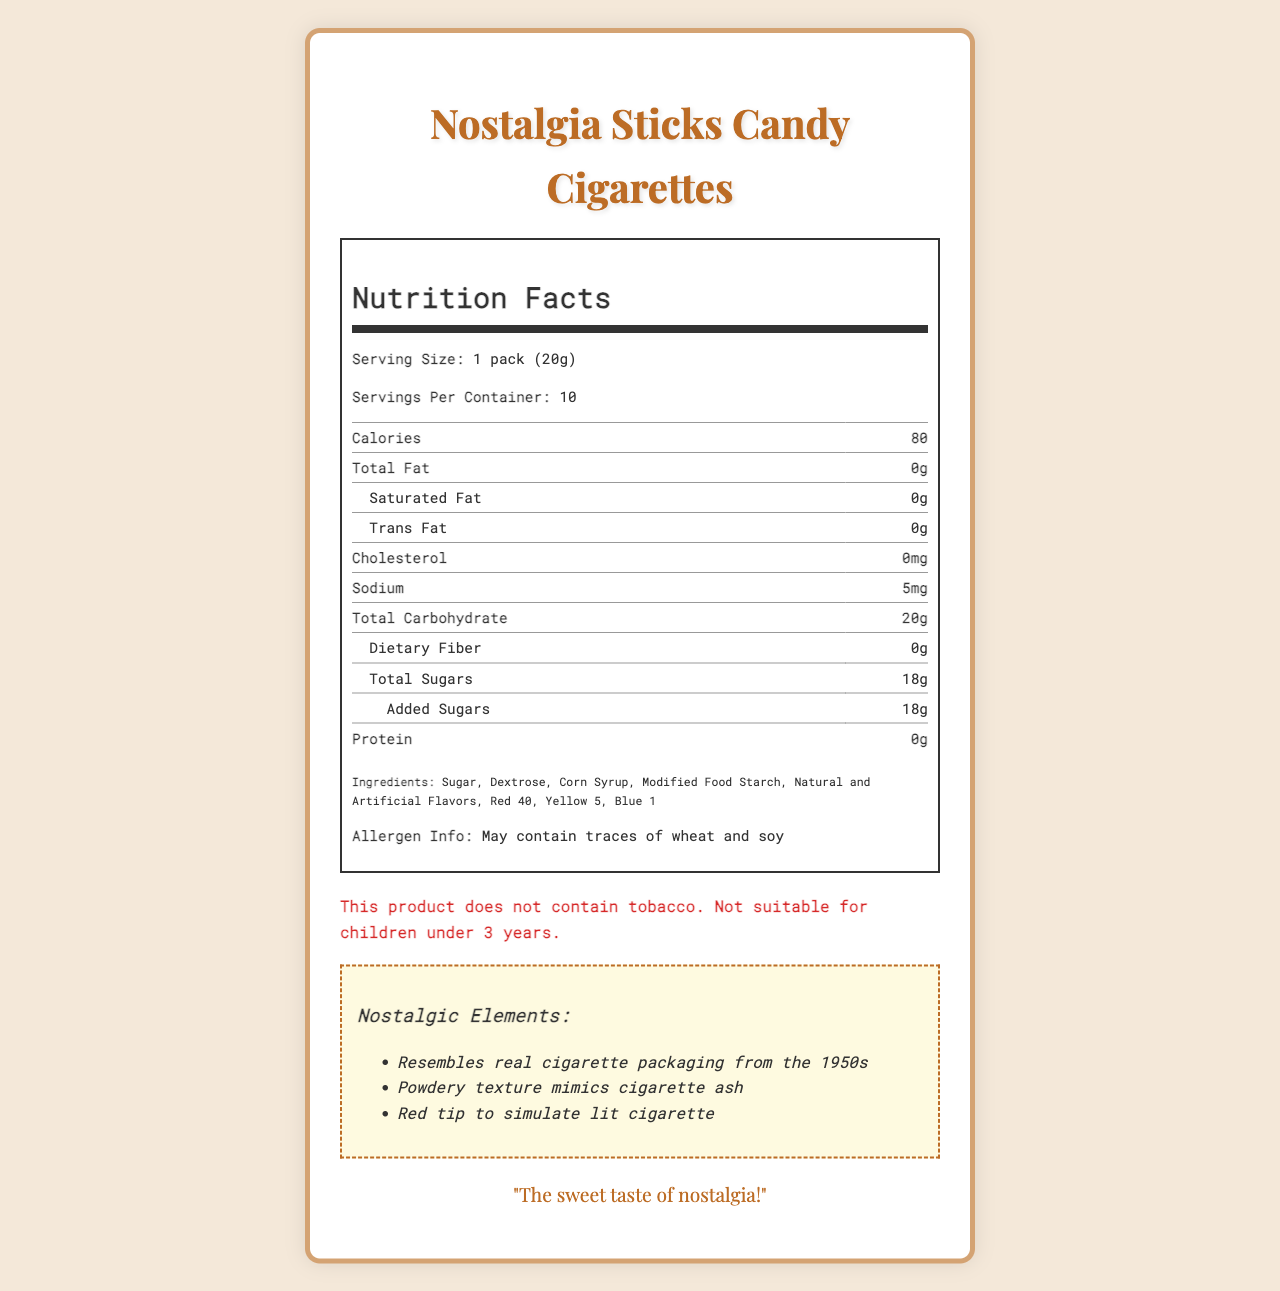what is the serving size for Nostalgia Sticks Candy Cigarettes? The document clearly states that the serving size is "1 pack (20g)."
Answer: 1 pack (20g) what is the total carbohydrate content per serving? The nutrition label lists the total carbohydrate content as 20g per serving.
Answer: 20g how many grams of sugar are in one serving? According to the nutrition label, there are 18g of total sugars per serving.
Answer: 18g which brand manufactures the Nostalgia Sticks Candy Cigarettes? The document specifies that the manufacturer is Retro Confections Inc.
Answer: Retro Confections Inc. list the artificial color additives used in Nostalgia Sticks Candy Cigarettes. The ingredients list includes Red 40, Yellow 5, and Blue 1 as artificial color additives.
Answer: Red 40, Yellow 5, Blue 1 does the product contain any dietary fiber? The nutrition facts indicate that the dietary fiber content is 0g.
Answer: No how many calories are in a single serving? The document states that each serving contains 80 calories.
Answer: 80 what is the tagline for the Nostalgia Sticks Candy Cigarettes? The packaging design section mentions the tagline as "The sweet taste of nostalgia!"
Answer: "The sweet taste of nostalgia!" what is the total fat content in a single serving? The total fat content per serving is listed as 0g in the nutrition facts.
Answer: 0g identify the primary ingredient in the Nostalgia Sticks Candy Cigarettes. The first item in the ingredients list is sugar, indicating it is the primary ingredient.
Answer: Sugar how many servings are in one container of Nostalgia Sticks Candy Cigarettes? The document states that there are 10 servings per container.
Answer: 10 which of the following vitamins and minerals are present in Nostalgia Sticks Candy Cigarettes? A. Vitamin D B. Calcium C. Iron D. None of the above The nutrition facts label shows all values for vitamin D, calcium, and iron as 0mg, indicating that none of these are present.
Answer: D. None of the above how does the packaging of Nostalgia Sticks Candy Cigarettes reflect a nostalgic theme? A. Modern graphics B. 1980s design C. Vintage 1950s style D. Futuristic elements The packaging design is described as having a "Vintage 1950s" style, which reflects a nostalgic theme.
Answer: C. Vintage 1950s style is the product suitable for children under 3 years old? The warning section states that the product is not suitable for children under 3 years.
Answer: No summarize the main idea of the document. The document includes the nutrition label, ingredients list, packaging design details, allergen information, and a warning. Additionally, it mentions the nostalgic elements of the product and its use as a prop in the political thriller "Thank You for Smoking."
Answer: The document provides detailed nutrition facts, ingredients, allergen information, and nostalgic elements of the "Nostalgia Sticks Candy Cigarettes." It highlights the high sugar content, vintage 1950s style packaging, and the manufacturer's identity, Retro Confections Inc. what is the total calorie content of an entire container? There are 10 servings per container, and each serving has 80 calories, so the total calorie content is 80 calories × 10 servings = 800 calories.
Answer: 800 calories does the product contain any ingredients derived from wheat or soy? The allergen information states that the product "May contain traces of wheat and soy."
Answer: May contain traces of wheat and soy what film featured the Nostalgia Sticks Candy Cigarettes as a popular prop? The product trivia mentions that this candy was a popular prop in the political thriller "Thank You for Smoking" (2005).
Answer: Thank You for Smoking (2005) how does the powdery texture of Nostalgia Sticks Candy Cigarettes add to its nostalgic appeal? The nostalgia section notes that the powdery texture mimics cigarette ash, adding to the nostalgic appeal.
Answer: Mimics cigarette ash can we determine the price of the Nostalgia Sticks Candy Cigarettes from the document? The document does not provide any information regarding the price of the candy cigarettes.
Answer: Cannot be determined 